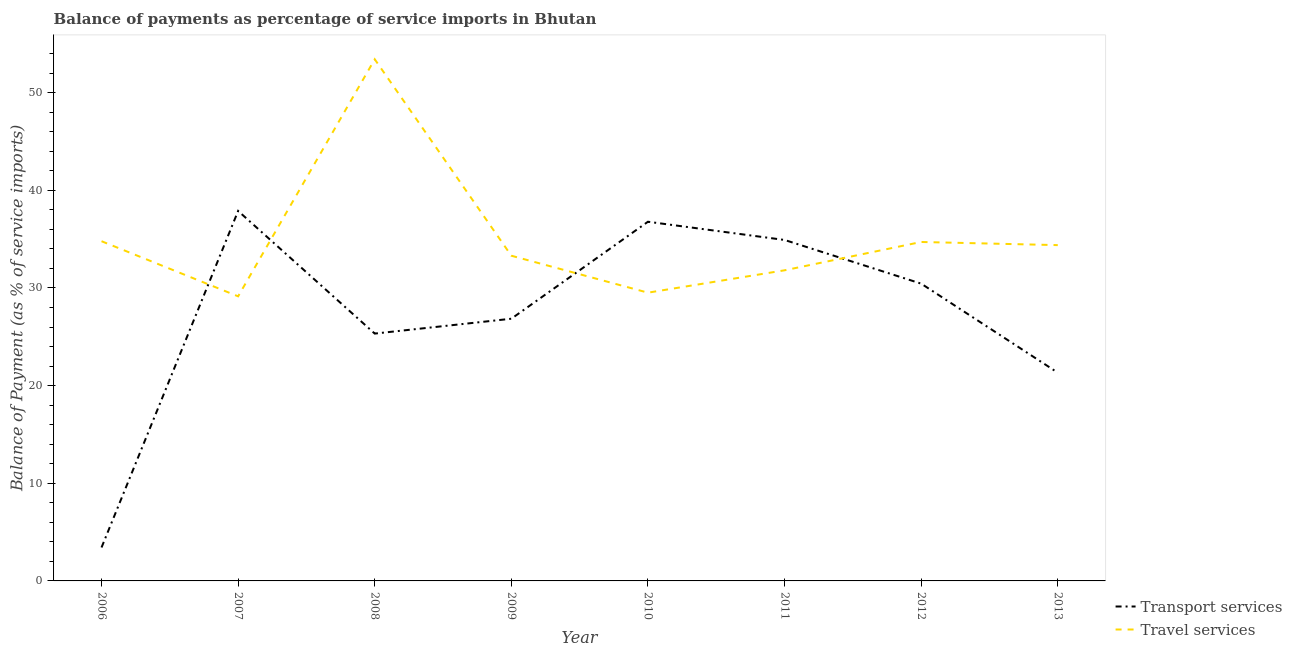How many different coloured lines are there?
Provide a succinct answer. 2. Does the line corresponding to balance of payments of transport services intersect with the line corresponding to balance of payments of travel services?
Give a very brief answer. Yes. What is the balance of payments of transport services in 2011?
Offer a terse response. 34.91. Across all years, what is the maximum balance of payments of transport services?
Your answer should be compact. 37.89. Across all years, what is the minimum balance of payments of travel services?
Your answer should be very brief. 29.14. In which year was the balance of payments of transport services maximum?
Offer a terse response. 2007. In which year was the balance of payments of transport services minimum?
Give a very brief answer. 2006. What is the total balance of payments of travel services in the graph?
Your answer should be very brief. 281.06. What is the difference between the balance of payments of transport services in 2010 and that in 2011?
Provide a succinct answer. 1.87. What is the difference between the balance of payments of travel services in 2012 and the balance of payments of transport services in 2011?
Offer a very short reply. -0.21. What is the average balance of payments of travel services per year?
Provide a short and direct response. 35.13. In the year 2009, what is the difference between the balance of payments of travel services and balance of payments of transport services?
Make the answer very short. 6.45. What is the ratio of the balance of payments of transport services in 2008 to that in 2012?
Keep it short and to the point. 0.83. Is the balance of payments of travel services in 2007 less than that in 2008?
Make the answer very short. Yes. Is the difference between the balance of payments of transport services in 2009 and 2012 greater than the difference between the balance of payments of travel services in 2009 and 2012?
Offer a very short reply. No. What is the difference between the highest and the second highest balance of payments of transport services?
Your answer should be very brief. 1.11. What is the difference between the highest and the lowest balance of payments of travel services?
Your answer should be compact. 24.27. In how many years, is the balance of payments of transport services greater than the average balance of payments of transport services taken over all years?
Provide a short and direct response. 4. Is the sum of the balance of payments of travel services in 2010 and 2012 greater than the maximum balance of payments of transport services across all years?
Offer a terse response. Yes. Does the balance of payments of travel services monotonically increase over the years?
Make the answer very short. No. Is the balance of payments of transport services strictly greater than the balance of payments of travel services over the years?
Your response must be concise. No. How many lines are there?
Make the answer very short. 2. What is the difference between two consecutive major ticks on the Y-axis?
Your answer should be compact. 10. Does the graph contain any zero values?
Your answer should be compact. No. Does the graph contain grids?
Offer a terse response. No. Where does the legend appear in the graph?
Offer a terse response. Bottom right. What is the title of the graph?
Make the answer very short. Balance of payments as percentage of service imports in Bhutan. What is the label or title of the X-axis?
Make the answer very short. Year. What is the label or title of the Y-axis?
Give a very brief answer. Balance of Payment (as % of service imports). What is the Balance of Payment (as % of service imports) of Transport services in 2006?
Your response must be concise. 3.42. What is the Balance of Payment (as % of service imports) of Travel services in 2006?
Your response must be concise. 34.79. What is the Balance of Payment (as % of service imports) in Transport services in 2007?
Provide a succinct answer. 37.89. What is the Balance of Payment (as % of service imports) in Travel services in 2007?
Provide a succinct answer. 29.14. What is the Balance of Payment (as % of service imports) in Transport services in 2008?
Make the answer very short. 25.33. What is the Balance of Payment (as % of service imports) in Travel services in 2008?
Provide a short and direct response. 53.42. What is the Balance of Payment (as % of service imports) in Transport services in 2009?
Your answer should be compact. 26.85. What is the Balance of Payment (as % of service imports) in Travel services in 2009?
Your answer should be compact. 33.3. What is the Balance of Payment (as % of service imports) of Transport services in 2010?
Ensure brevity in your answer.  36.78. What is the Balance of Payment (as % of service imports) in Travel services in 2010?
Make the answer very short. 29.52. What is the Balance of Payment (as % of service imports) in Transport services in 2011?
Your response must be concise. 34.91. What is the Balance of Payment (as % of service imports) of Travel services in 2011?
Make the answer very short. 31.81. What is the Balance of Payment (as % of service imports) of Transport services in 2012?
Your answer should be very brief. 30.44. What is the Balance of Payment (as % of service imports) in Travel services in 2012?
Make the answer very short. 34.71. What is the Balance of Payment (as % of service imports) of Transport services in 2013?
Your answer should be compact. 21.32. What is the Balance of Payment (as % of service imports) in Travel services in 2013?
Offer a very short reply. 34.39. Across all years, what is the maximum Balance of Payment (as % of service imports) of Transport services?
Give a very brief answer. 37.89. Across all years, what is the maximum Balance of Payment (as % of service imports) of Travel services?
Make the answer very short. 53.42. Across all years, what is the minimum Balance of Payment (as % of service imports) of Transport services?
Ensure brevity in your answer.  3.42. Across all years, what is the minimum Balance of Payment (as % of service imports) of Travel services?
Your response must be concise. 29.14. What is the total Balance of Payment (as % of service imports) of Transport services in the graph?
Offer a very short reply. 216.95. What is the total Balance of Payment (as % of service imports) in Travel services in the graph?
Provide a short and direct response. 281.06. What is the difference between the Balance of Payment (as % of service imports) in Transport services in 2006 and that in 2007?
Offer a very short reply. -34.46. What is the difference between the Balance of Payment (as % of service imports) of Travel services in 2006 and that in 2007?
Your answer should be very brief. 5.64. What is the difference between the Balance of Payment (as % of service imports) in Transport services in 2006 and that in 2008?
Ensure brevity in your answer.  -21.9. What is the difference between the Balance of Payment (as % of service imports) in Travel services in 2006 and that in 2008?
Offer a very short reply. -18.63. What is the difference between the Balance of Payment (as % of service imports) in Transport services in 2006 and that in 2009?
Give a very brief answer. -23.42. What is the difference between the Balance of Payment (as % of service imports) of Travel services in 2006 and that in 2009?
Give a very brief answer. 1.49. What is the difference between the Balance of Payment (as % of service imports) of Transport services in 2006 and that in 2010?
Offer a terse response. -33.36. What is the difference between the Balance of Payment (as % of service imports) of Travel services in 2006 and that in 2010?
Offer a terse response. 5.27. What is the difference between the Balance of Payment (as % of service imports) of Transport services in 2006 and that in 2011?
Ensure brevity in your answer.  -31.49. What is the difference between the Balance of Payment (as % of service imports) of Travel services in 2006 and that in 2011?
Ensure brevity in your answer.  2.98. What is the difference between the Balance of Payment (as % of service imports) of Transport services in 2006 and that in 2012?
Make the answer very short. -27.02. What is the difference between the Balance of Payment (as % of service imports) of Travel services in 2006 and that in 2012?
Offer a very short reply. 0.08. What is the difference between the Balance of Payment (as % of service imports) of Transport services in 2006 and that in 2013?
Provide a short and direct response. -17.9. What is the difference between the Balance of Payment (as % of service imports) in Transport services in 2007 and that in 2008?
Ensure brevity in your answer.  12.56. What is the difference between the Balance of Payment (as % of service imports) of Travel services in 2007 and that in 2008?
Keep it short and to the point. -24.27. What is the difference between the Balance of Payment (as % of service imports) in Transport services in 2007 and that in 2009?
Provide a short and direct response. 11.04. What is the difference between the Balance of Payment (as % of service imports) of Travel services in 2007 and that in 2009?
Ensure brevity in your answer.  -4.16. What is the difference between the Balance of Payment (as % of service imports) of Transport services in 2007 and that in 2010?
Provide a succinct answer. 1.11. What is the difference between the Balance of Payment (as % of service imports) in Travel services in 2007 and that in 2010?
Provide a short and direct response. -0.37. What is the difference between the Balance of Payment (as % of service imports) of Transport services in 2007 and that in 2011?
Make the answer very short. 2.97. What is the difference between the Balance of Payment (as % of service imports) in Travel services in 2007 and that in 2011?
Your response must be concise. -2.67. What is the difference between the Balance of Payment (as % of service imports) of Transport services in 2007 and that in 2012?
Offer a terse response. 7.44. What is the difference between the Balance of Payment (as % of service imports) of Travel services in 2007 and that in 2012?
Your answer should be very brief. -5.57. What is the difference between the Balance of Payment (as % of service imports) of Transport services in 2007 and that in 2013?
Keep it short and to the point. 16.56. What is the difference between the Balance of Payment (as % of service imports) in Travel services in 2007 and that in 2013?
Provide a succinct answer. -5.24. What is the difference between the Balance of Payment (as % of service imports) in Transport services in 2008 and that in 2009?
Offer a very short reply. -1.52. What is the difference between the Balance of Payment (as % of service imports) of Travel services in 2008 and that in 2009?
Provide a succinct answer. 20.11. What is the difference between the Balance of Payment (as % of service imports) in Transport services in 2008 and that in 2010?
Ensure brevity in your answer.  -11.45. What is the difference between the Balance of Payment (as % of service imports) in Travel services in 2008 and that in 2010?
Keep it short and to the point. 23.9. What is the difference between the Balance of Payment (as % of service imports) of Transport services in 2008 and that in 2011?
Offer a very short reply. -9.59. What is the difference between the Balance of Payment (as % of service imports) of Travel services in 2008 and that in 2011?
Offer a terse response. 21.61. What is the difference between the Balance of Payment (as % of service imports) of Transport services in 2008 and that in 2012?
Make the answer very short. -5.12. What is the difference between the Balance of Payment (as % of service imports) in Travel services in 2008 and that in 2012?
Keep it short and to the point. 18.71. What is the difference between the Balance of Payment (as % of service imports) of Transport services in 2008 and that in 2013?
Your response must be concise. 4. What is the difference between the Balance of Payment (as % of service imports) of Travel services in 2008 and that in 2013?
Ensure brevity in your answer.  19.03. What is the difference between the Balance of Payment (as % of service imports) in Transport services in 2009 and that in 2010?
Ensure brevity in your answer.  -9.93. What is the difference between the Balance of Payment (as % of service imports) of Travel services in 2009 and that in 2010?
Provide a succinct answer. 3.78. What is the difference between the Balance of Payment (as % of service imports) in Transport services in 2009 and that in 2011?
Your response must be concise. -8.07. What is the difference between the Balance of Payment (as % of service imports) of Travel services in 2009 and that in 2011?
Make the answer very short. 1.49. What is the difference between the Balance of Payment (as % of service imports) of Transport services in 2009 and that in 2012?
Offer a very short reply. -3.59. What is the difference between the Balance of Payment (as % of service imports) of Travel services in 2009 and that in 2012?
Provide a short and direct response. -1.41. What is the difference between the Balance of Payment (as % of service imports) in Transport services in 2009 and that in 2013?
Offer a terse response. 5.52. What is the difference between the Balance of Payment (as % of service imports) of Travel services in 2009 and that in 2013?
Make the answer very short. -1.09. What is the difference between the Balance of Payment (as % of service imports) of Transport services in 2010 and that in 2011?
Ensure brevity in your answer.  1.87. What is the difference between the Balance of Payment (as % of service imports) of Travel services in 2010 and that in 2011?
Your answer should be compact. -2.29. What is the difference between the Balance of Payment (as % of service imports) of Transport services in 2010 and that in 2012?
Provide a succinct answer. 6.34. What is the difference between the Balance of Payment (as % of service imports) of Travel services in 2010 and that in 2012?
Provide a short and direct response. -5.19. What is the difference between the Balance of Payment (as % of service imports) in Transport services in 2010 and that in 2013?
Keep it short and to the point. 15.46. What is the difference between the Balance of Payment (as % of service imports) of Travel services in 2010 and that in 2013?
Provide a succinct answer. -4.87. What is the difference between the Balance of Payment (as % of service imports) in Transport services in 2011 and that in 2012?
Give a very brief answer. 4.47. What is the difference between the Balance of Payment (as % of service imports) in Transport services in 2011 and that in 2013?
Ensure brevity in your answer.  13.59. What is the difference between the Balance of Payment (as % of service imports) of Travel services in 2011 and that in 2013?
Keep it short and to the point. -2.58. What is the difference between the Balance of Payment (as % of service imports) in Transport services in 2012 and that in 2013?
Give a very brief answer. 9.12. What is the difference between the Balance of Payment (as % of service imports) in Travel services in 2012 and that in 2013?
Your response must be concise. 0.32. What is the difference between the Balance of Payment (as % of service imports) of Transport services in 2006 and the Balance of Payment (as % of service imports) of Travel services in 2007?
Offer a terse response. -25.72. What is the difference between the Balance of Payment (as % of service imports) of Transport services in 2006 and the Balance of Payment (as % of service imports) of Travel services in 2008?
Give a very brief answer. -49.99. What is the difference between the Balance of Payment (as % of service imports) of Transport services in 2006 and the Balance of Payment (as % of service imports) of Travel services in 2009?
Provide a short and direct response. -29.88. What is the difference between the Balance of Payment (as % of service imports) of Transport services in 2006 and the Balance of Payment (as % of service imports) of Travel services in 2010?
Provide a succinct answer. -26.09. What is the difference between the Balance of Payment (as % of service imports) in Transport services in 2006 and the Balance of Payment (as % of service imports) in Travel services in 2011?
Offer a terse response. -28.38. What is the difference between the Balance of Payment (as % of service imports) of Transport services in 2006 and the Balance of Payment (as % of service imports) of Travel services in 2012?
Your answer should be compact. -31.28. What is the difference between the Balance of Payment (as % of service imports) of Transport services in 2006 and the Balance of Payment (as % of service imports) of Travel services in 2013?
Your answer should be very brief. -30.96. What is the difference between the Balance of Payment (as % of service imports) in Transport services in 2007 and the Balance of Payment (as % of service imports) in Travel services in 2008?
Your answer should be very brief. -15.53. What is the difference between the Balance of Payment (as % of service imports) of Transport services in 2007 and the Balance of Payment (as % of service imports) of Travel services in 2009?
Your answer should be compact. 4.59. What is the difference between the Balance of Payment (as % of service imports) in Transport services in 2007 and the Balance of Payment (as % of service imports) in Travel services in 2010?
Make the answer very short. 8.37. What is the difference between the Balance of Payment (as % of service imports) in Transport services in 2007 and the Balance of Payment (as % of service imports) in Travel services in 2011?
Keep it short and to the point. 6.08. What is the difference between the Balance of Payment (as % of service imports) in Transport services in 2007 and the Balance of Payment (as % of service imports) in Travel services in 2012?
Offer a terse response. 3.18. What is the difference between the Balance of Payment (as % of service imports) of Transport services in 2007 and the Balance of Payment (as % of service imports) of Travel services in 2013?
Make the answer very short. 3.5. What is the difference between the Balance of Payment (as % of service imports) in Transport services in 2008 and the Balance of Payment (as % of service imports) in Travel services in 2009?
Make the answer very short. -7.97. What is the difference between the Balance of Payment (as % of service imports) in Transport services in 2008 and the Balance of Payment (as % of service imports) in Travel services in 2010?
Your answer should be compact. -4.19. What is the difference between the Balance of Payment (as % of service imports) of Transport services in 2008 and the Balance of Payment (as % of service imports) of Travel services in 2011?
Give a very brief answer. -6.48. What is the difference between the Balance of Payment (as % of service imports) of Transport services in 2008 and the Balance of Payment (as % of service imports) of Travel services in 2012?
Keep it short and to the point. -9.38. What is the difference between the Balance of Payment (as % of service imports) of Transport services in 2008 and the Balance of Payment (as % of service imports) of Travel services in 2013?
Your response must be concise. -9.06. What is the difference between the Balance of Payment (as % of service imports) in Transport services in 2009 and the Balance of Payment (as % of service imports) in Travel services in 2010?
Your response must be concise. -2.67. What is the difference between the Balance of Payment (as % of service imports) of Transport services in 2009 and the Balance of Payment (as % of service imports) of Travel services in 2011?
Offer a terse response. -4.96. What is the difference between the Balance of Payment (as % of service imports) in Transport services in 2009 and the Balance of Payment (as % of service imports) in Travel services in 2012?
Your answer should be compact. -7.86. What is the difference between the Balance of Payment (as % of service imports) in Transport services in 2009 and the Balance of Payment (as % of service imports) in Travel services in 2013?
Give a very brief answer. -7.54. What is the difference between the Balance of Payment (as % of service imports) of Transport services in 2010 and the Balance of Payment (as % of service imports) of Travel services in 2011?
Provide a short and direct response. 4.97. What is the difference between the Balance of Payment (as % of service imports) of Transport services in 2010 and the Balance of Payment (as % of service imports) of Travel services in 2012?
Your response must be concise. 2.07. What is the difference between the Balance of Payment (as % of service imports) of Transport services in 2010 and the Balance of Payment (as % of service imports) of Travel services in 2013?
Offer a very short reply. 2.39. What is the difference between the Balance of Payment (as % of service imports) in Transport services in 2011 and the Balance of Payment (as % of service imports) in Travel services in 2012?
Provide a succinct answer. 0.21. What is the difference between the Balance of Payment (as % of service imports) of Transport services in 2011 and the Balance of Payment (as % of service imports) of Travel services in 2013?
Offer a terse response. 0.53. What is the difference between the Balance of Payment (as % of service imports) of Transport services in 2012 and the Balance of Payment (as % of service imports) of Travel services in 2013?
Offer a terse response. -3.94. What is the average Balance of Payment (as % of service imports) of Transport services per year?
Ensure brevity in your answer.  27.12. What is the average Balance of Payment (as % of service imports) in Travel services per year?
Your answer should be very brief. 35.13. In the year 2006, what is the difference between the Balance of Payment (as % of service imports) in Transport services and Balance of Payment (as % of service imports) in Travel services?
Provide a succinct answer. -31.36. In the year 2007, what is the difference between the Balance of Payment (as % of service imports) in Transport services and Balance of Payment (as % of service imports) in Travel services?
Keep it short and to the point. 8.74. In the year 2008, what is the difference between the Balance of Payment (as % of service imports) in Transport services and Balance of Payment (as % of service imports) in Travel services?
Provide a short and direct response. -28.09. In the year 2009, what is the difference between the Balance of Payment (as % of service imports) of Transport services and Balance of Payment (as % of service imports) of Travel services?
Your response must be concise. -6.45. In the year 2010, what is the difference between the Balance of Payment (as % of service imports) of Transport services and Balance of Payment (as % of service imports) of Travel services?
Your answer should be very brief. 7.26. In the year 2011, what is the difference between the Balance of Payment (as % of service imports) of Transport services and Balance of Payment (as % of service imports) of Travel services?
Your response must be concise. 3.11. In the year 2012, what is the difference between the Balance of Payment (as % of service imports) in Transport services and Balance of Payment (as % of service imports) in Travel services?
Offer a very short reply. -4.26. In the year 2013, what is the difference between the Balance of Payment (as % of service imports) of Transport services and Balance of Payment (as % of service imports) of Travel services?
Give a very brief answer. -13.06. What is the ratio of the Balance of Payment (as % of service imports) in Transport services in 2006 to that in 2007?
Your answer should be compact. 0.09. What is the ratio of the Balance of Payment (as % of service imports) in Travel services in 2006 to that in 2007?
Your response must be concise. 1.19. What is the ratio of the Balance of Payment (as % of service imports) of Transport services in 2006 to that in 2008?
Provide a short and direct response. 0.14. What is the ratio of the Balance of Payment (as % of service imports) in Travel services in 2006 to that in 2008?
Keep it short and to the point. 0.65. What is the ratio of the Balance of Payment (as % of service imports) of Transport services in 2006 to that in 2009?
Make the answer very short. 0.13. What is the ratio of the Balance of Payment (as % of service imports) in Travel services in 2006 to that in 2009?
Your response must be concise. 1.04. What is the ratio of the Balance of Payment (as % of service imports) of Transport services in 2006 to that in 2010?
Offer a terse response. 0.09. What is the ratio of the Balance of Payment (as % of service imports) of Travel services in 2006 to that in 2010?
Keep it short and to the point. 1.18. What is the ratio of the Balance of Payment (as % of service imports) in Transport services in 2006 to that in 2011?
Make the answer very short. 0.1. What is the ratio of the Balance of Payment (as % of service imports) of Travel services in 2006 to that in 2011?
Your answer should be very brief. 1.09. What is the ratio of the Balance of Payment (as % of service imports) in Transport services in 2006 to that in 2012?
Keep it short and to the point. 0.11. What is the ratio of the Balance of Payment (as % of service imports) of Transport services in 2006 to that in 2013?
Your answer should be very brief. 0.16. What is the ratio of the Balance of Payment (as % of service imports) in Travel services in 2006 to that in 2013?
Your answer should be compact. 1.01. What is the ratio of the Balance of Payment (as % of service imports) of Transport services in 2007 to that in 2008?
Your answer should be very brief. 1.5. What is the ratio of the Balance of Payment (as % of service imports) in Travel services in 2007 to that in 2008?
Give a very brief answer. 0.55. What is the ratio of the Balance of Payment (as % of service imports) of Transport services in 2007 to that in 2009?
Offer a terse response. 1.41. What is the ratio of the Balance of Payment (as % of service imports) in Travel services in 2007 to that in 2009?
Your answer should be compact. 0.88. What is the ratio of the Balance of Payment (as % of service imports) of Travel services in 2007 to that in 2010?
Your answer should be very brief. 0.99. What is the ratio of the Balance of Payment (as % of service imports) of Transport services in 2007 to that in 2011?
Offer a very short reply. 1.09. What is the ratio of the Balance of Payment (as % of service imports) of Travel services in 2007 to that in 2011?
Offer a very short reply. 0.92. What is the ratio of the Balance of Payment (as % of service imports) in Transport services in 2007 to that in 2012?
Provide a succinct answer. 1.24. What is the ratio of the Balance of Payment (as % of service imports) of Travel services in 2007 to that in 2012?
Provide a short and direct response. 0.84. What is the ratio of the Balance of Payment (as % of service imports) of Transport services in 2007 to that in 2013?
Provide a short and direct response. 1.78. What is the ratio of the Balance of Payment (as % of service imports) of Travel services in 2007 to that in 2013?
Offer a very short reply. 0.85. What is the ratio of the Balance of Payment (as % of service imports) in Transport services in 2008 to that in 2009?
Make the answer very short. 0.94. What is the ratio of the Balance of Payment (as % of service imports) in Travel services in 2008 to that in 2009?
Offer a terse response. 1.6. What is the ratio of the Balance of Payment (as % of service imports) in Transport services in 2008 to that in 2010?
Keep it short and to the point. 0.69. What is the ratio of the Balance of Payment (as % of service imports) of Travel services in 2008 to that in 2010?
Ensure brevity in your answer.  1.81. What is the ratio of the Balance of Payment (as % of service imports) of Transport services in 2008 to that in 2011?
Offer a terse response. 0.73. What is the ratio of the Balance of Payment (as % of service imports) in Travel services in 2008 to that in 2011?
Your response must be concise. 1.68. What is the ratio of the Balance of Payment (as % of service imports) in Transport services in 2008 to that in 2012?
Offer a terse response. 0.83. What is the ratio of the Balance of Payment (as % of service imports) in Travel services in 2008 to that in 2012?
Your answer should be very brief. 1.54. What is the ratio of the Balance of Payment (as % of service imports) in Transport services in 2008 to that in 2013?
Offer a very short reply. 1.19. What is the ratio of the Balance of Payment (as % of service imports) of Travel services in 2008 to that in 2013?
Ensure brevity in your answer.  1.55. What is the ratio of the Balance of Payment (as % of service imports) of Transport services in 2009 to that in 2010?
Offer a very short reply. 0.73. What is the ratio of the Balance of Payment (as % of service imports) of Travel services in 2009 to that in 2010?
Your response must be concise. 1.13. What is the ratio of the Balance of Payment (as % of service imports) of Transport services in 2009 to that in 2011?
Make the answer very short. 0.77. What is the ratio of the Balance of Payment (as % of service imports) of Travel services in 2009 to that in 2011?
Give a very brief answer. 1.05. What is the ratio of the Balance of Payment (as % of service imports) of Transport services in 2009 to that in 2012?
Offer a terse response. 0.88. What is the ratio of the Balance of Payment (as % of service imports) in Travel services in 2009 to that in 2012?
Your answer should be very brief. 0.96. What is the ratio of the Balance of Payment (as % of service imports) of Transport services in 2009 to that in 2013?
Provide a succinct answer. 1.26. What is the ratio of the Balance of Payment (as % of service imports) in Travel services in 2009 to that in 2013?
Provide a succinct answer. 0.97. What is the ratio of the Balance of Payment (as % of service imports) of Transport services in 2010 to that in 2011?
Keep it short and to the point. 1.05. What is the ratio of the Balance of Payment (as % of service imports) in Travel services in 2010 to that in 2011?
Your answer should be compact. 0.93. What is the ratio of the Balance of Payment (as % of service imports) in Transport services in 2010 to that in 2012?
Provide a short and direct response. 1.21. What is the ratio of the Balance of Payment (as % of service imports) in Travel services in 2010 to that in 2012?
Offer a terse response. 0.85. What is the ratio of the Balance of Payment (as % of service imports) in Transport services in 2010 to that in 2013?
Make the answer very short. 1.72. What is the ratio of the Balance of Payment (as % of service imports) of Travel services in 2010 to that in 2013?
Your answer should be compact. 0.86. What is the ratio of the Balance of Payment (as % of service imports) of Transport services in 2011 to that in 2012?
Offer a terse response. 1.15. What is the ratio of the Balance of Payment (as % of service imports) in Travel services in 2011 to that in 2012?
Give a very brief answer. 0.92. What is the ratio of the Balance of Payment (as % of service imports) of Transport services in 2011 to that in 2013?
Make the answer very short. 1.64. What is the ratio of the Balance of Payment (as % of service imports) of Travel services in 2011 to that in 2013?
Offer a very short reply. 0.93. What is the ratio of the Balance of Payment (as % of service imports) of Transport services in 2012 to that in 2013?
Give a very brief answer. 1.43. What is the ratio of the Balance of Payment (as % of service imports) in Travel services in 2012 to that in 2013?
Make the answer very short. 1.01. What is the difference between the highest and the second highest Balance of Payment (as % of service imports) in Transport services?
Ensure brevity in your answer.  1.11. What is the difference between the highest and the second highest Balance of Payment (as % of service imports) of Travel services?
Your answer should be compact. 18.63. What is the difference between the highest and the lowest Balance of Payment (as % of service imports) in Transport services?
Give a very brief answer. 34.46. What is the difference between the highest and the lowest Balance of Payment (as % of service imports) of Travel services?
Offer a very short reply. 24.27. 